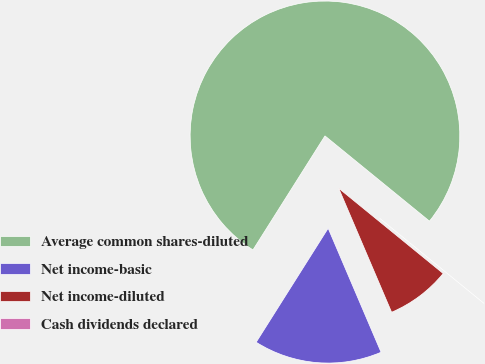Convert chart. <chart><loc_0><loc_0><loc_500><loc_500><pie_chart><fcel>Average common shares-diluted<fcel>Net income-basic<fcel>Net income-diluted<fcel>Cash dividends declared<nl><fcel>76.92%<fcel>15.38%<fcel>7.69%<fcel>0.0%<nl></chart> 